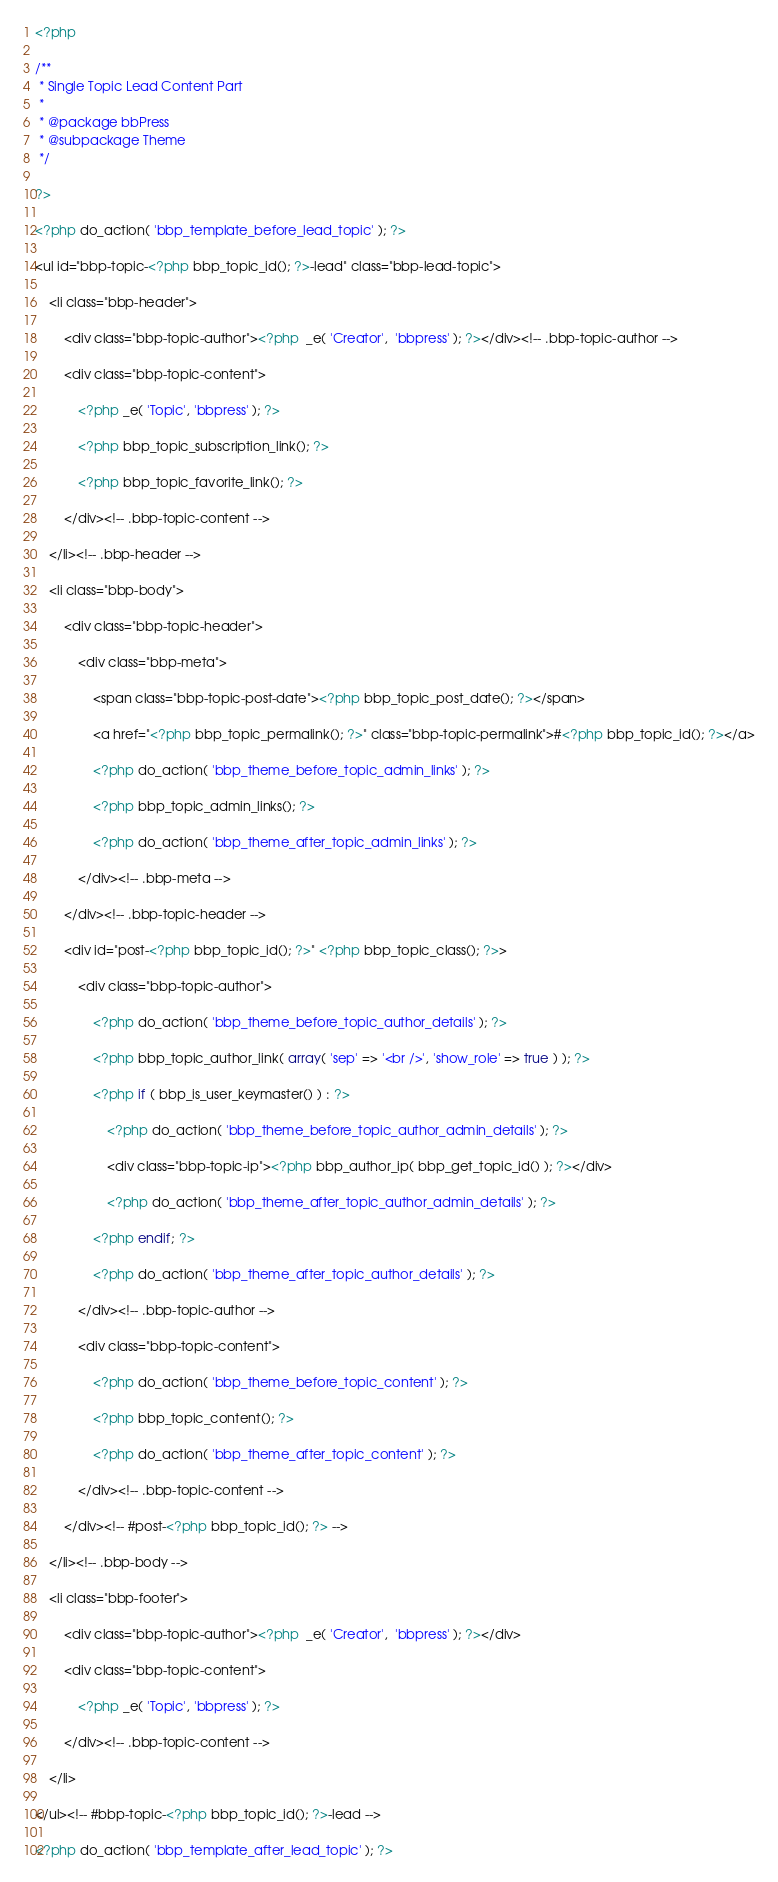Convert code to text. <code><loc_0><loc_0><loc_500><loc_500><_PHP_><?php

/**
 * Single Topic Lead Content Part
 *
 * @package bbPress
 * @subpackage Theme
 */

?>

<?php do_action( 'bbp_template_before_lead_topic' ); ?>

<ul id="bbp-topic-<?php bbp_topic_id(); ?>-lead" class="bbp-lead-topic">

	<li class="bbp-header">

		<div class="bbp-topic-author"><?php  _e( 'Creator',  'bbpress' ); ?></div><!-- .bbp-topic-author -->

		<div class="bbp-topic-content">

			<?php _e( 'Topic', 'bbpress' ); ?>

			<?php bbp_topic_subscription_link(); ?>

			<?php bbp_topic_favorite_link(); ?>

		</div><!-- .bbp-topic-content -->

	</li><!-- .bbp-header -->

	<li class="bbp-body">

		<div class="bbp-topic-header">

			<div class="bbp-meta">

				<span class="bbp-topic-post-date"><?php bbp_topic_post_date(); ?></span>

				<a href="<?php bbp_topic_permalink(); ?>" class="bbp-topic-permalink">#<?php bbp_topic_id(); ?></a>

				<?php do_action( 'bbp_theme_before_topic_admin_links' ); ?>

				<?php bbp_topic_admin_links(); ?>

				<?php do_action( 'bbp_theme_after_topic_admin_links' ); ?>

			</div><!-- .bbp-meta -->

		</div><!-- .bbp-topic-header -->

		<div id="post-<?php bbp_topic_id(); ?>" <?php bbp_topic_class(); ?>>

			<div class="bbp-topic-author">

				<?php do_action( 'bbp_theme_before_topic_author_details' ); ?>

				<?php bbp_topic_author_link( array( 'sep' => '<br />', 'show_role' => true ) ); ?>

				<?php if ( bbp_is_user_keymaster() ) : ?>

					<?php do_action( 'bbp_theme_before_topic_author_admin_details' ); ?>

					<div class="bbp-topic-ip"><?php bbp_author_ip( bbp_get_topic_id() ); ?></div>

					<?php do_action( 'bbp_theme_after_topic_author_admin_details' ); ?>

				<?php endif; ?>

				<?php do_action( 'bbp_theme_after_topic_author_details' ); ?>

			</div><!-- .bbp-topic-author -->

			<div class="bbp-topic-content">

				<?php do_action( 'bbp_theme_before_topic_content' ); ?>

				<?php bbp_topic_content(); ?>

				<?php do_action( 'bbp_theme_after_topic_content' ); ?>

			</div><!-- .bbp-topic-content -->

		</div><!-- #post-<?php bbp_topic_id(); ?> -->

	</li><!-- .bbp-body -->

	<li class="bbp-footer">

		<div class="bbp-topic-author"><?php  _e( 'Creator',  'bbpress' ); ?></div>

		<div class="bbp-topic-content">

			<?php _e( 'Topic', 'bbpress' ); ?>

		</div><!-- .bbp-topic-content -->

	</li>

</ul><!-- #bbp-topic-<?php bbp_topic_id(); ?>-lead -->

<?php do_action( 'bbp_template_after_lead_topic' ); ?>
</code> 